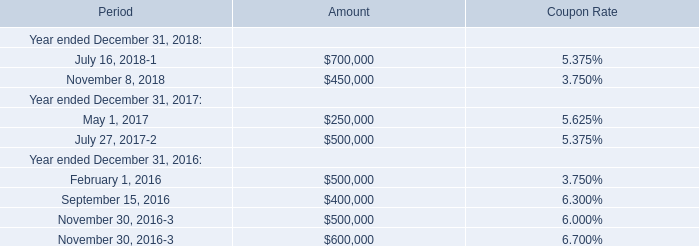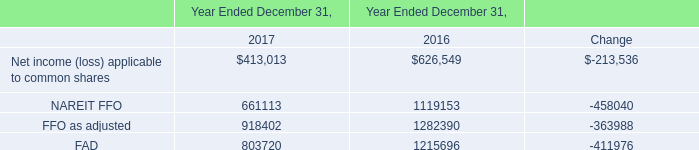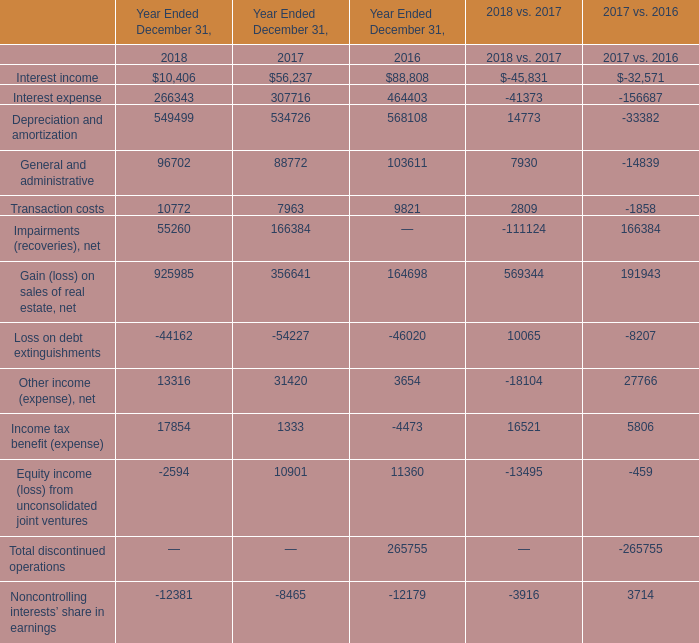What is the average amount of General and administrative of 2017 vs. 2016, and FAD of Year Ended December 31, 2017 ? 
Computations: ((14839.0 + 803720.0) / 2)
Answer: 409279.5. 